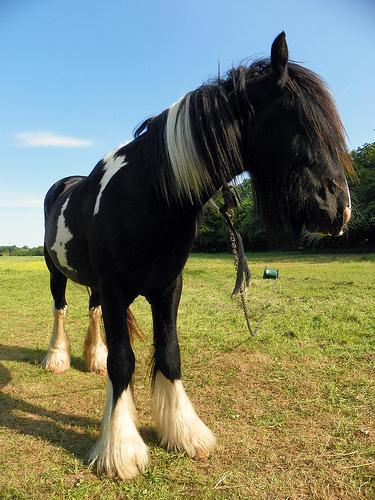Question: where is the picture taken?
Choices:
A. In a barn.
B. In the dairy house.
C. By the silos.
D. A pasture.
Answer with the letter. Answer: D Question: what animal is seen?
Choices:
A. Sheep.
B. Cow.
C. Horse.
D. Goat.
Answer with the letter. Answer: C Question: what is the horse doing?
Choices:
A. Eating.
B. Running.
C. Rolling.
D. Standing.
Answer with the letter. Answer: D Question: what is the color of the grass?
Choices:
A. Brown.
B. Gold.
C. Grey.
D. Green.
Answer with the letter. Answer: D Question: what is the color of the sky?
Choices:
A. Grey.
B. Blue.
C. Black.
D. Orange.
Answer with the letter. Answer: B 